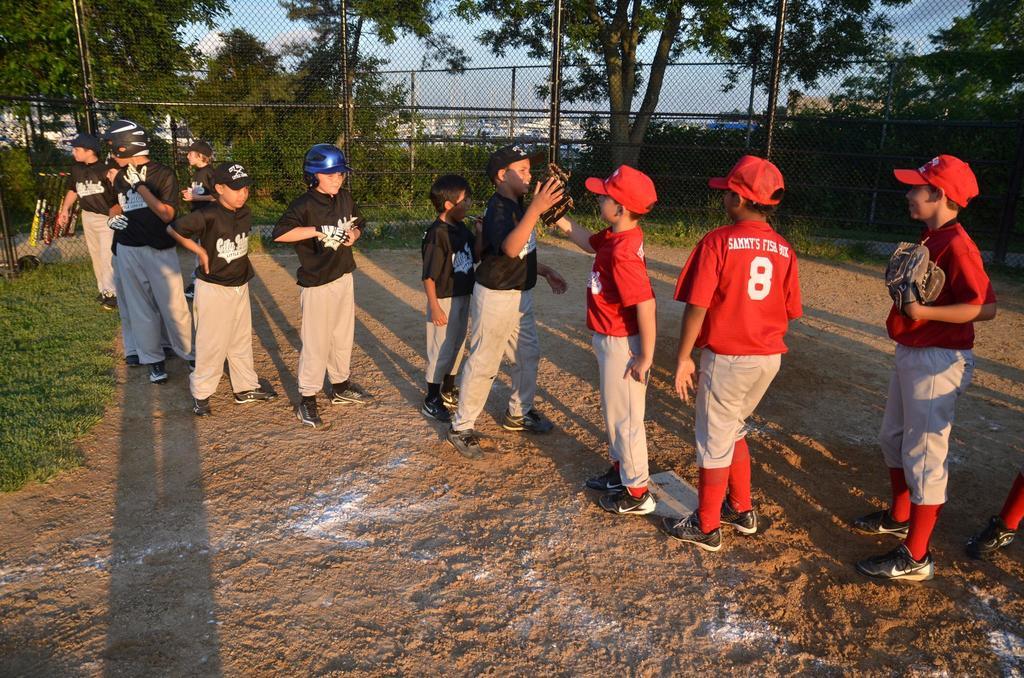The number is eight?
Offer a terse response. Yes. 